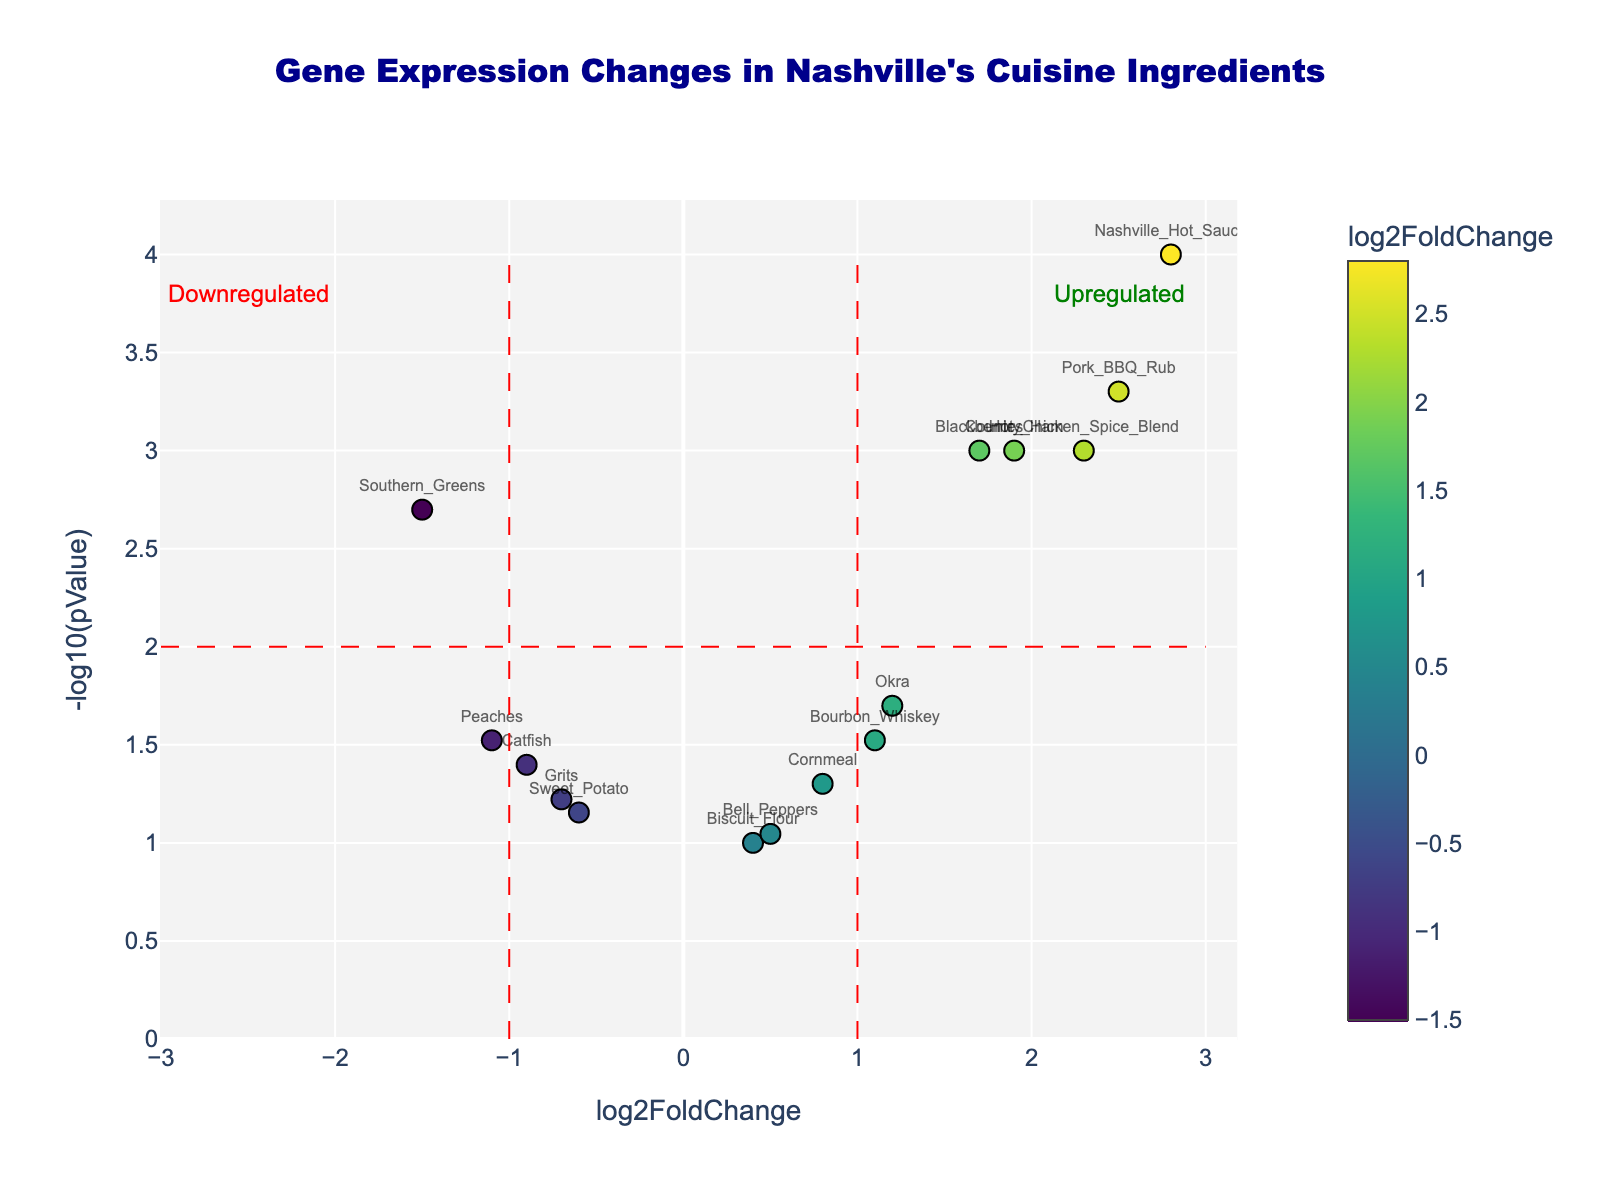What's the title of the plot? The title of the plot is usually located at the top center of the figure and is often the largest text element.
Answer: Gene Expression Changes in Nashville's Cuisine Ingredients How many genes are identified as significantly upregulated? Genes significantly upregulated have a log2FoldChange > 1 and -log10(pValue) > 2, indicated by text within the "Upregulated" quadrant.
Answer: 4 Which gene shows the highest level of upregulation? The highest upregulation is indicated by the highest log2FoldChange value on the x-axis in the positive direction.
Answer: Nashville_Hot_Sauce What is the log2FoldChange of Southern_Greens? Find Southern_Greens on the plot and note its horizontal (x-axis) position.
Answer: -1.5 Which ingredient has the smallest p-value? The smallest p-value corresponds to the highest -log10(pValue) on the y-axis.
Answer: Nashville_Hot_Sauce What are the log2FoldChange and p-value of Catfish? For Catfish, observe its position and hover text to obtain the data points.
Answer: log2FoldChange: -0.9, p-value: 0.04 Do more ingredients have increased or decreased gene expression changes? Compare the number of data points to the right of log2FoldChange = 0 (upregulated) to those on the left (downregulated).
Answer: Increased What is the most downregulated gene? The most downregulated gene is identified by the lowest log2FoldChange value in the negative direction.
Answer: Southern_Greens How many genes have negligible changes based on the plot? Negligible changes are near the log2FoldChange = 0 line and do not pass significance lines for -log10(pValue). Inspect the plot.
Answer: 2 Which ingredient has a log2FoldChange closest to zero but still significant? Check for the gene close to the log2FoldChange = 0 line but with a high -log10(pValue) making it significant.
Answer: Cornmeal 